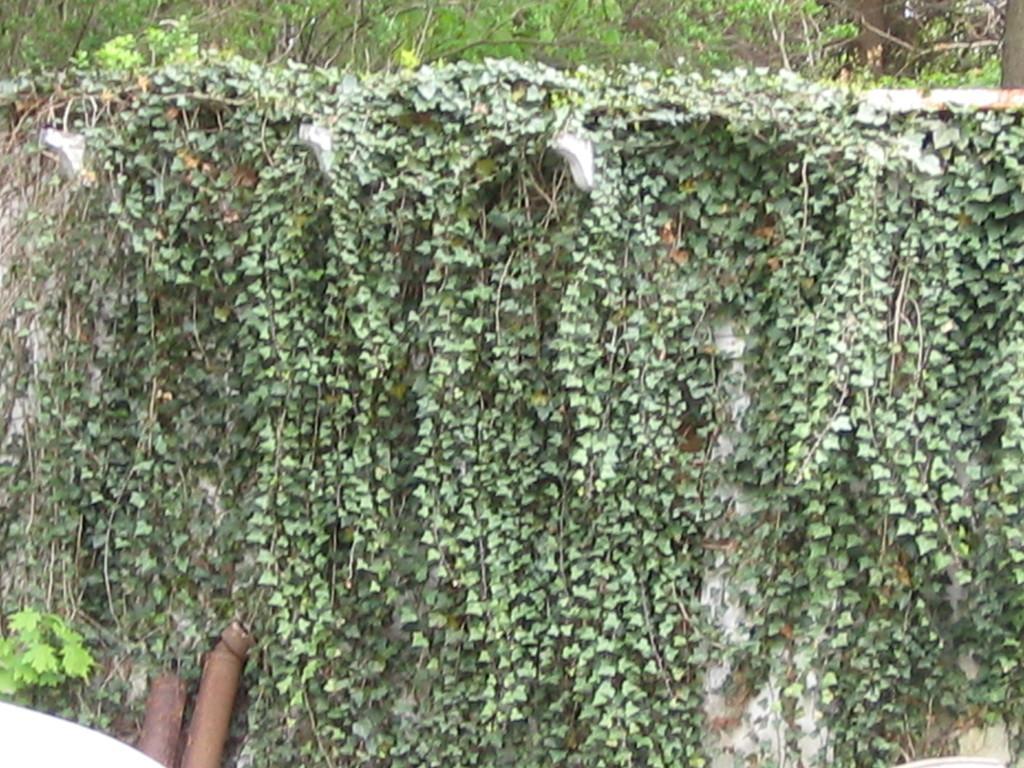In one or two sentences, can you explain what this image depicts? In this picture I can see plants and some other objects over here. 